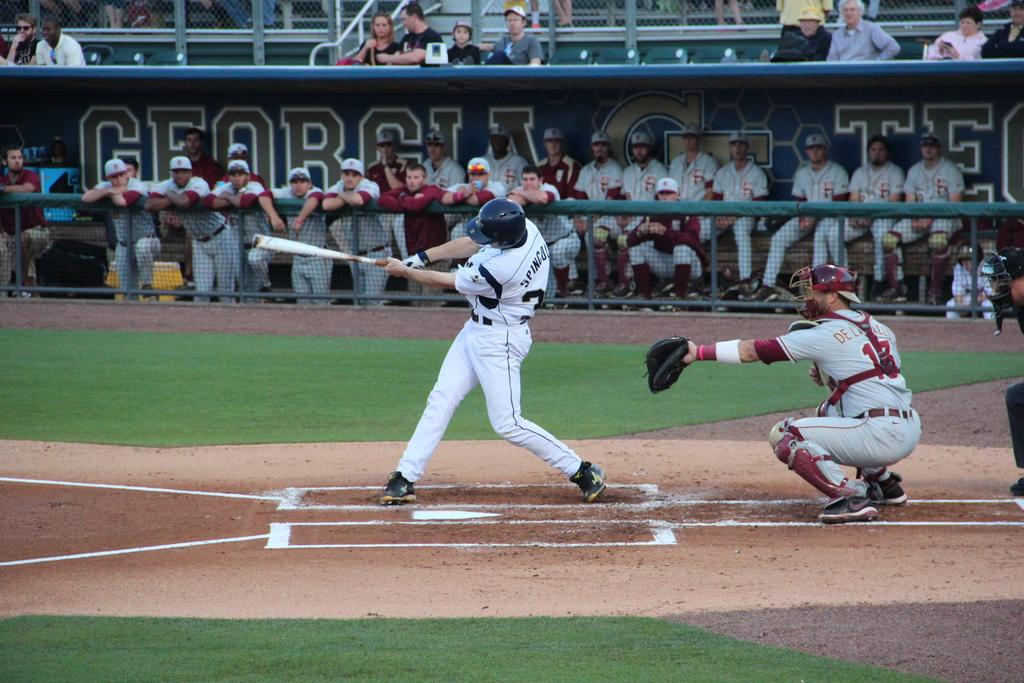<image>
Describe the image concisely. players in the georgia tech dugout watching the hitter 